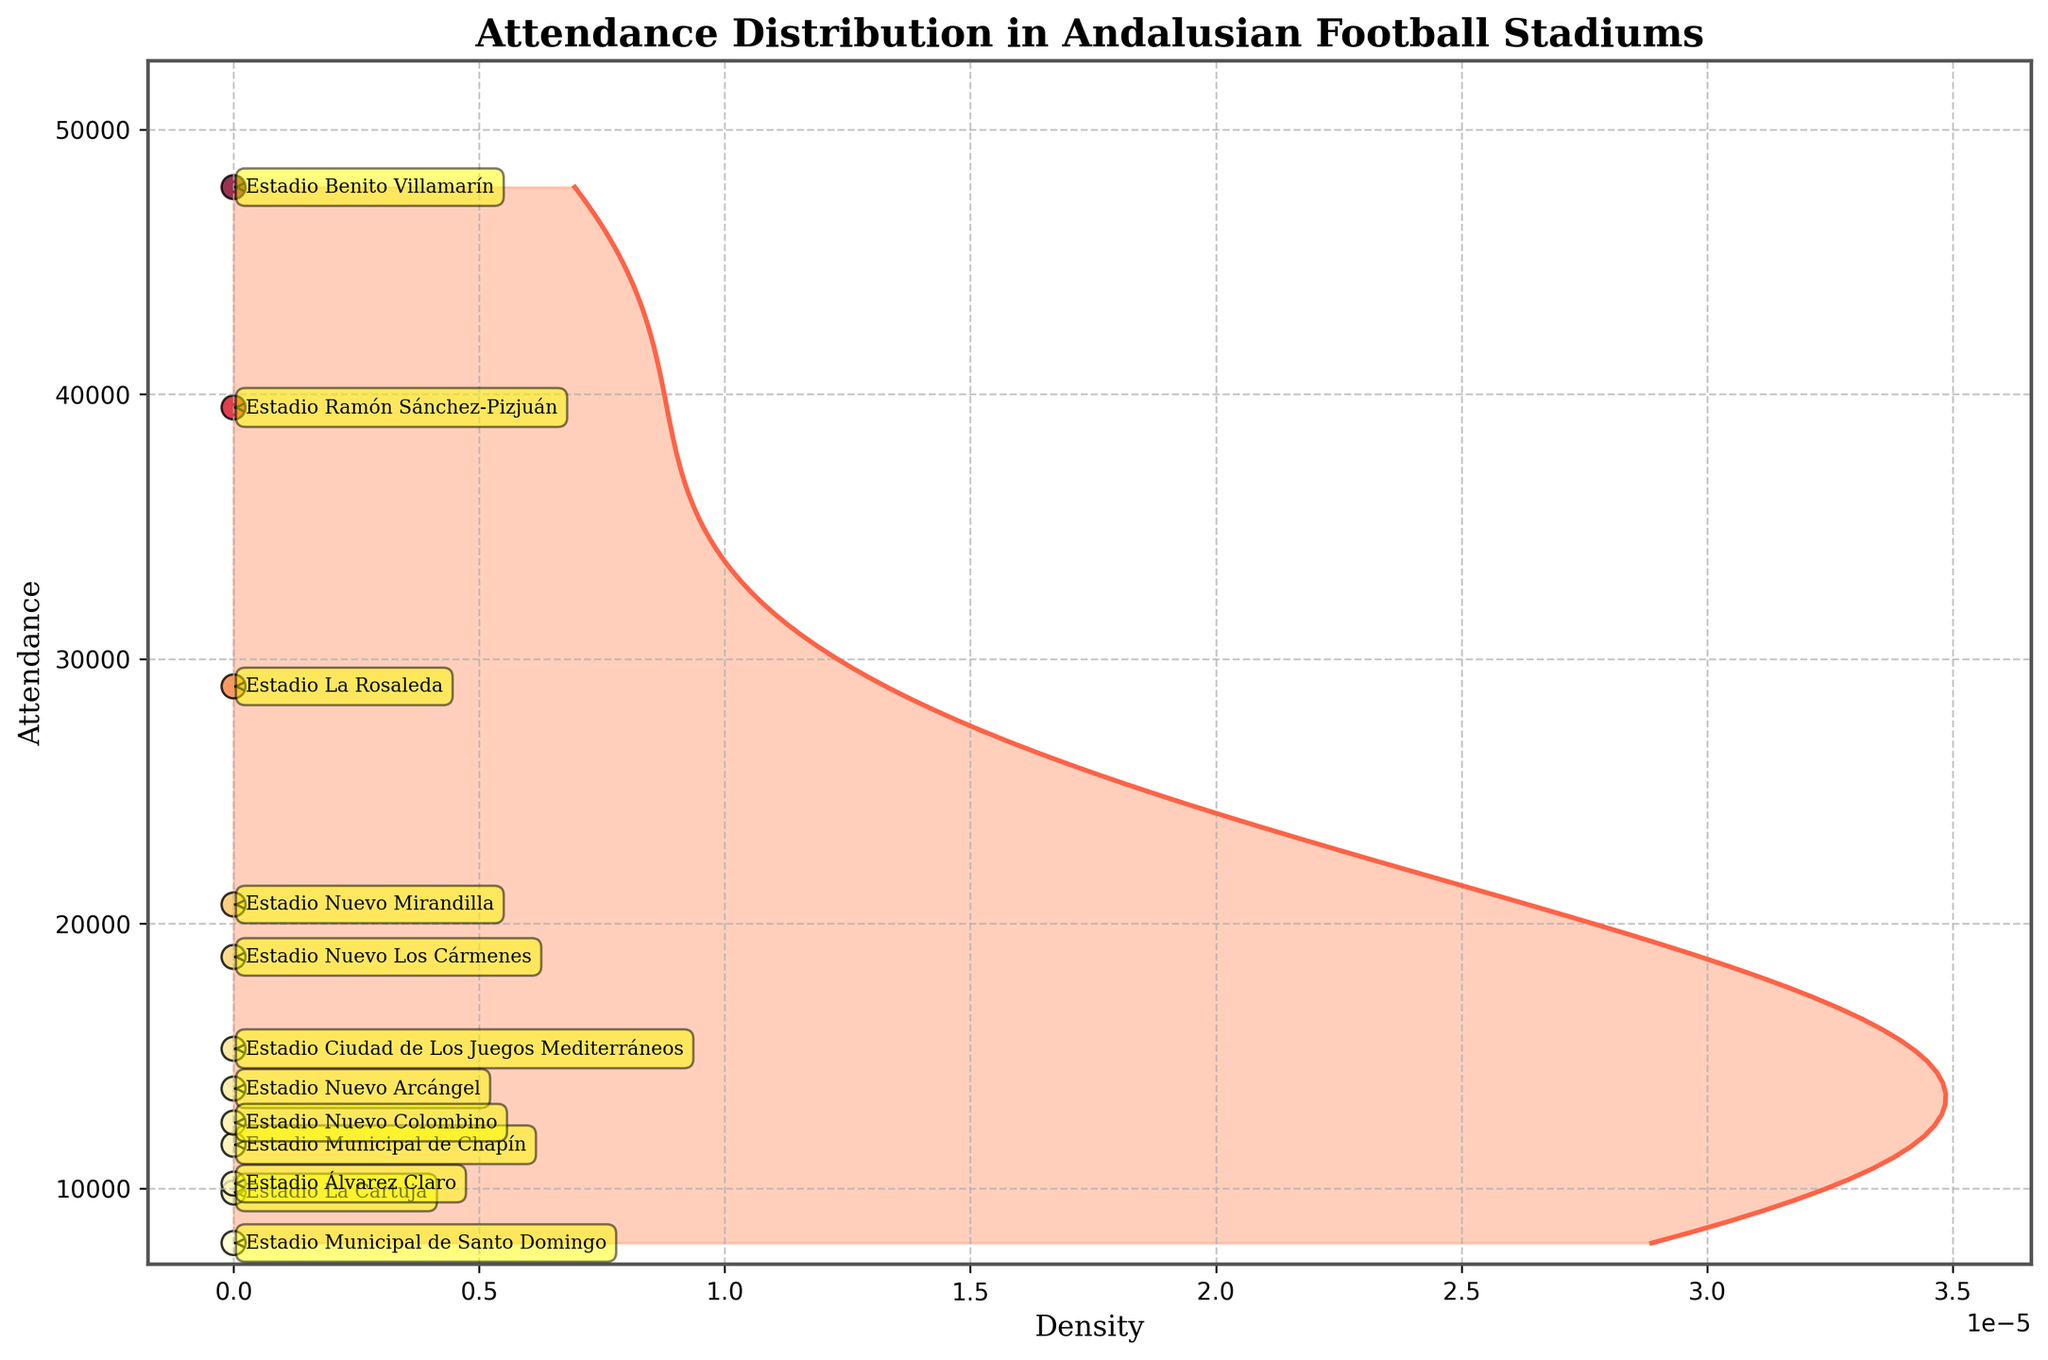What is the title of the plot? The title of the plot can be seen at the top of the figure.
Answer: Attendance Distribution in Andalusian Football Stadiums What does the x-axis represent? The x-axis label is marked as 'Density', indicating it represents the density of attendance figures.
Answer: Density How many stadiums have an attendance figure above 30,000? By counting all the data points (dots) plotted above the 30,000 mark on the y-axis, we identify the stadiums.
Answer: Two Which stadium has the lowest attendance figure? The lowest data point on the y-axis corresponds to the 'Estadio Municipal de Santo Domingo'.
Answer: Estadio Municipal de Santo Domingo Which stadiums have attendance figures closest to 10,000? By looking at the plot and identifying the points closest to the 10,000 mark, we find 'Estadio Álvarez Claro' and 'Estadio La Cartuja'.
Answer: Estadio Álvarez Claro and Estadio La Cartuja Compare the attendance figures between Estadio Ramón Sánchez-Pizjuán and Estadio La Rosaleda. Which one is higher? By checking the relative height of these two points on the y-axis, it is clear that 'Estadio Ramón Sánchez-Pizjuán' is higher.
Answer: Estadio Ramón Sánchez-Pizjuán What is the average attendance figure for all the stadiums? To find the average, sum all attendance figures and divide by the number of stadiums. (47823 + 39500 + 28963 + 18744 + 20724 + 15274 + 13771 + 7936 + 9845 + 11648 + 12485 + 10181) / 12 = 22556.25
Answer: 22556 Compare the densities of stadiums with attendance figures above 20,000 and below 20,000. By visually inspecting the density plot's shape across these regions, we can see a higher density below 20,000.
Answer: Higher density below 20,000 Which stadium has the highest attendance figure and what is that figure? Identifying the top-most data point on the y-axis corresponds to 'Estadio Benito Villamarín' with a figure of 47,823.
Answer: Estadio Benito Villamarín, 47,823 What pattern do you observe in the attendance distribution based on density? The density plot shows a higher concentration of stadiums around the mid-lower attendance range (below 20K), with fewer stadiums in the higher attendance range (above 30K).
Answer: Higher concentration below 20K 